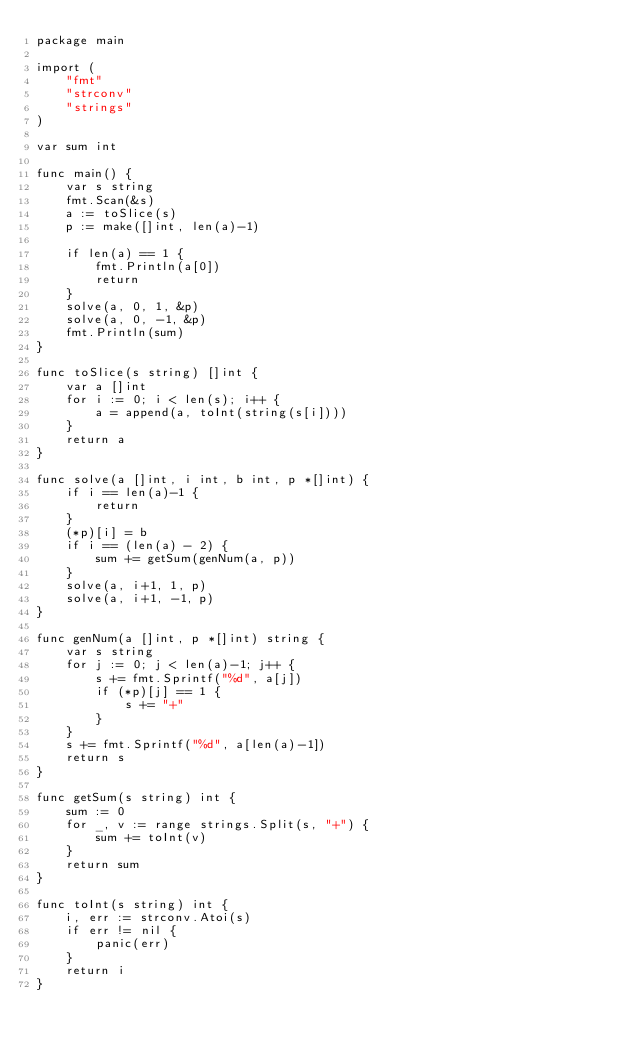<code> <loc_0><loc_0><loc_500><loc_500><_Go_>package main

import (
	"fmt"
	"strconv"
	"strings"
)

var sum int

func main() {
	var s string
	fmt.Scan(&s)
	a := toSlice(s)
	p := make([]int, len(a)-1)

	if len(a) == 1 {
		fmt.Println(a[0])
		return
	}
	solve(a, 0, 1, &p)
	solve(a, 0, -1, &p)
	fmt.Println(sum)
}

func toSlice(s string) []int {
	var a []int
	for i := 0; i < len(s); i++ {
		a = append(a, toInt(string(s[i])))
	}
	return a
}

func solve(a []int, i int, b int, p *[]int) {
	if i == len(a)-1 {
		return
	}
	(*p)[i] = b
	if i == (len(a) - 2) {
		sum += getSum(genNum(a, p))
	}
	solve(a, i+1, 1, p)
	solve(a, i+1, -1, p)
}

func genNum(a []int, p *[]int) string {
	var s string
	for j := 0; j < len(a)-1; j++ {
		s += fmt.Sprintf("%d", a[j])
		if (*p)[j] == 1 {
			s += "+"
		}
	}
	s += fmt.Sprintf("%d", a[len(a)-1])
	return s
}

func getSum(s string) int {
	sum := 0
	for _, v := range strings.Split(s, "+") {
		sum += toInt(v)
	}
	return sum
}

func toInt(s string) int {
	i, err := strconv.Atoi(s)
	if err != nil {
		panic(err)
	}
	return i
}
</code> 